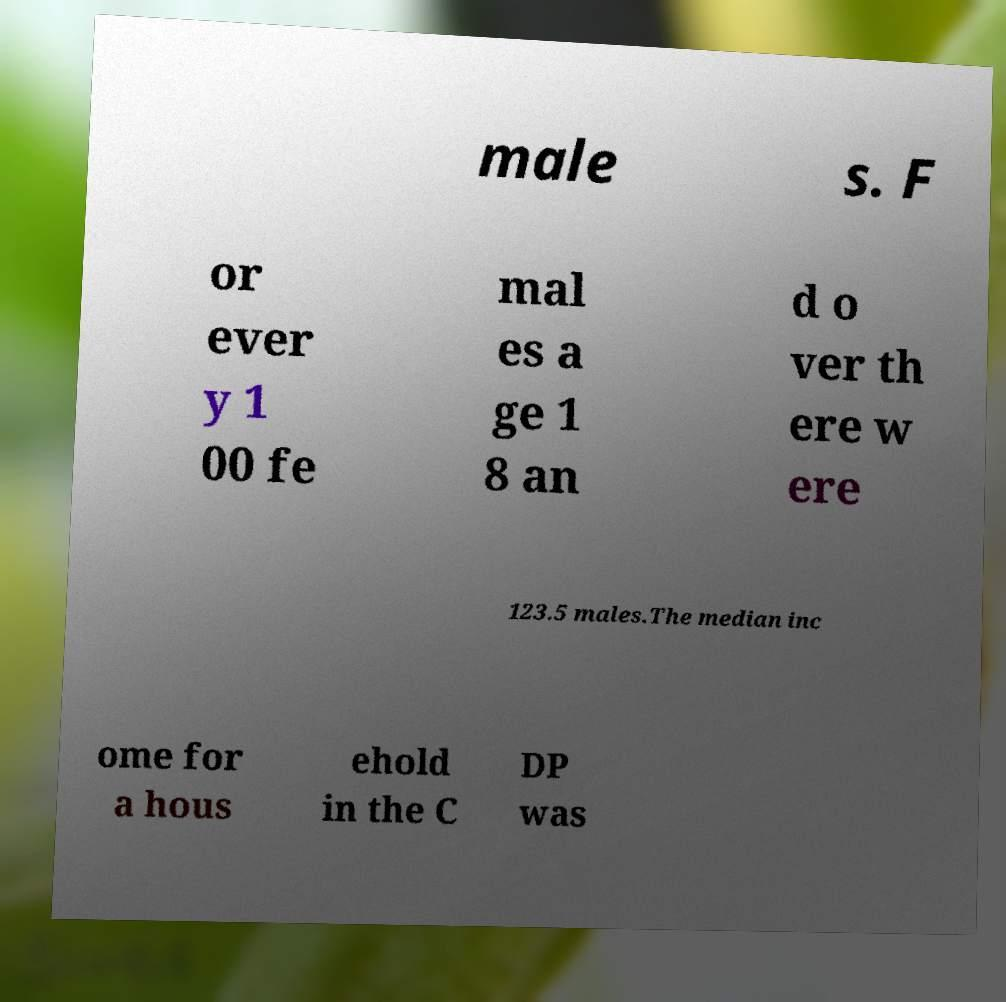Can you read and provide the text displayed in the image?This photo seems to have some interesting text. Can you extract and type it out for me? male s. F or ever y 1 00 fe mal es a ge 1 8 an d o ver th ere w ere 123.5 males.The median inc ome for a hous ehold in the C DP was 